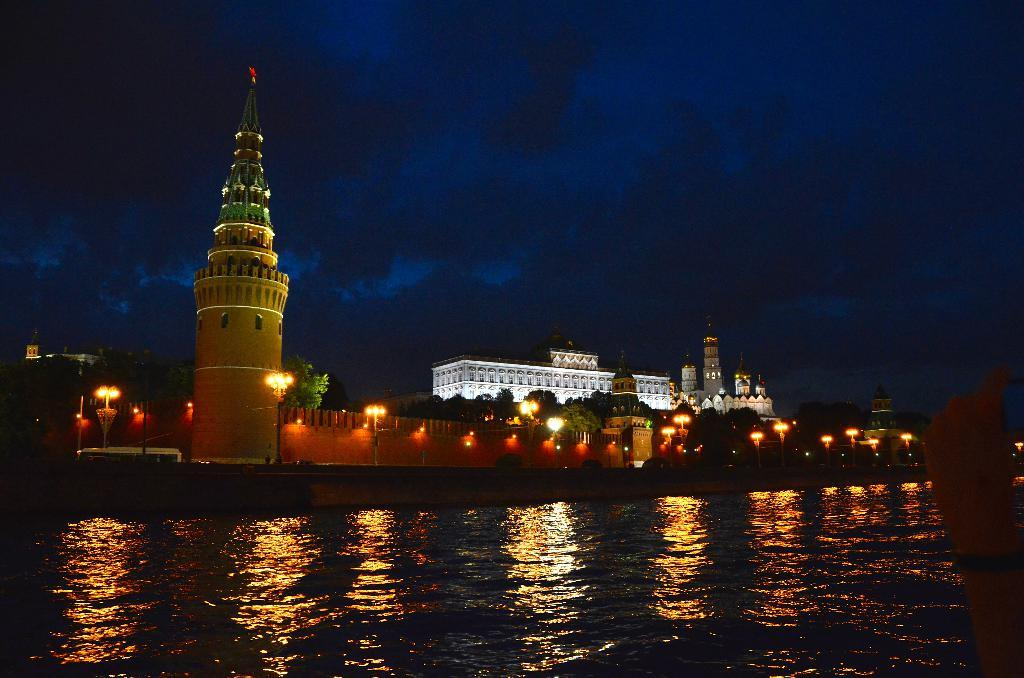What is visible in the image? Water is visible in the image. What can be seen in the background of the image? There is a building, lights, and trees in the background of the image. How many oranges are hanging from the trees in the image? There are no oranges visible in the image; only trees are present in the background. 